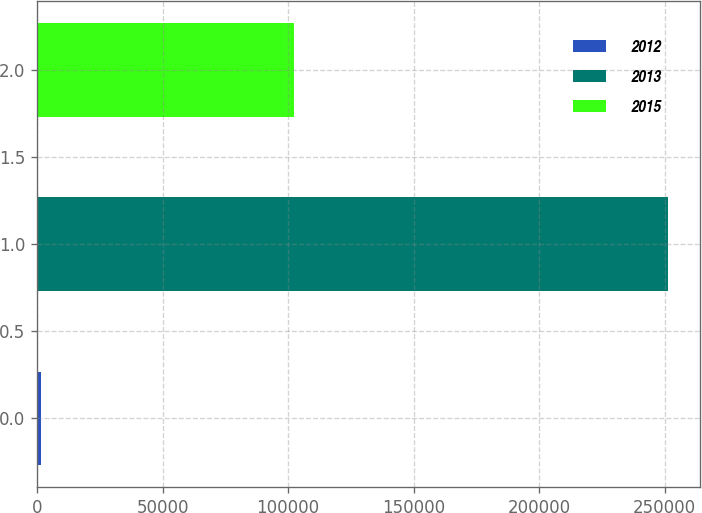<chart> <loc_0><loc_0><loc_500><loc_500><bar_chart><fcel>2012<fcel>2013<fcel>2015<nl><fcel>1409<fcel>251416<fcel>102175<nl></chart> 